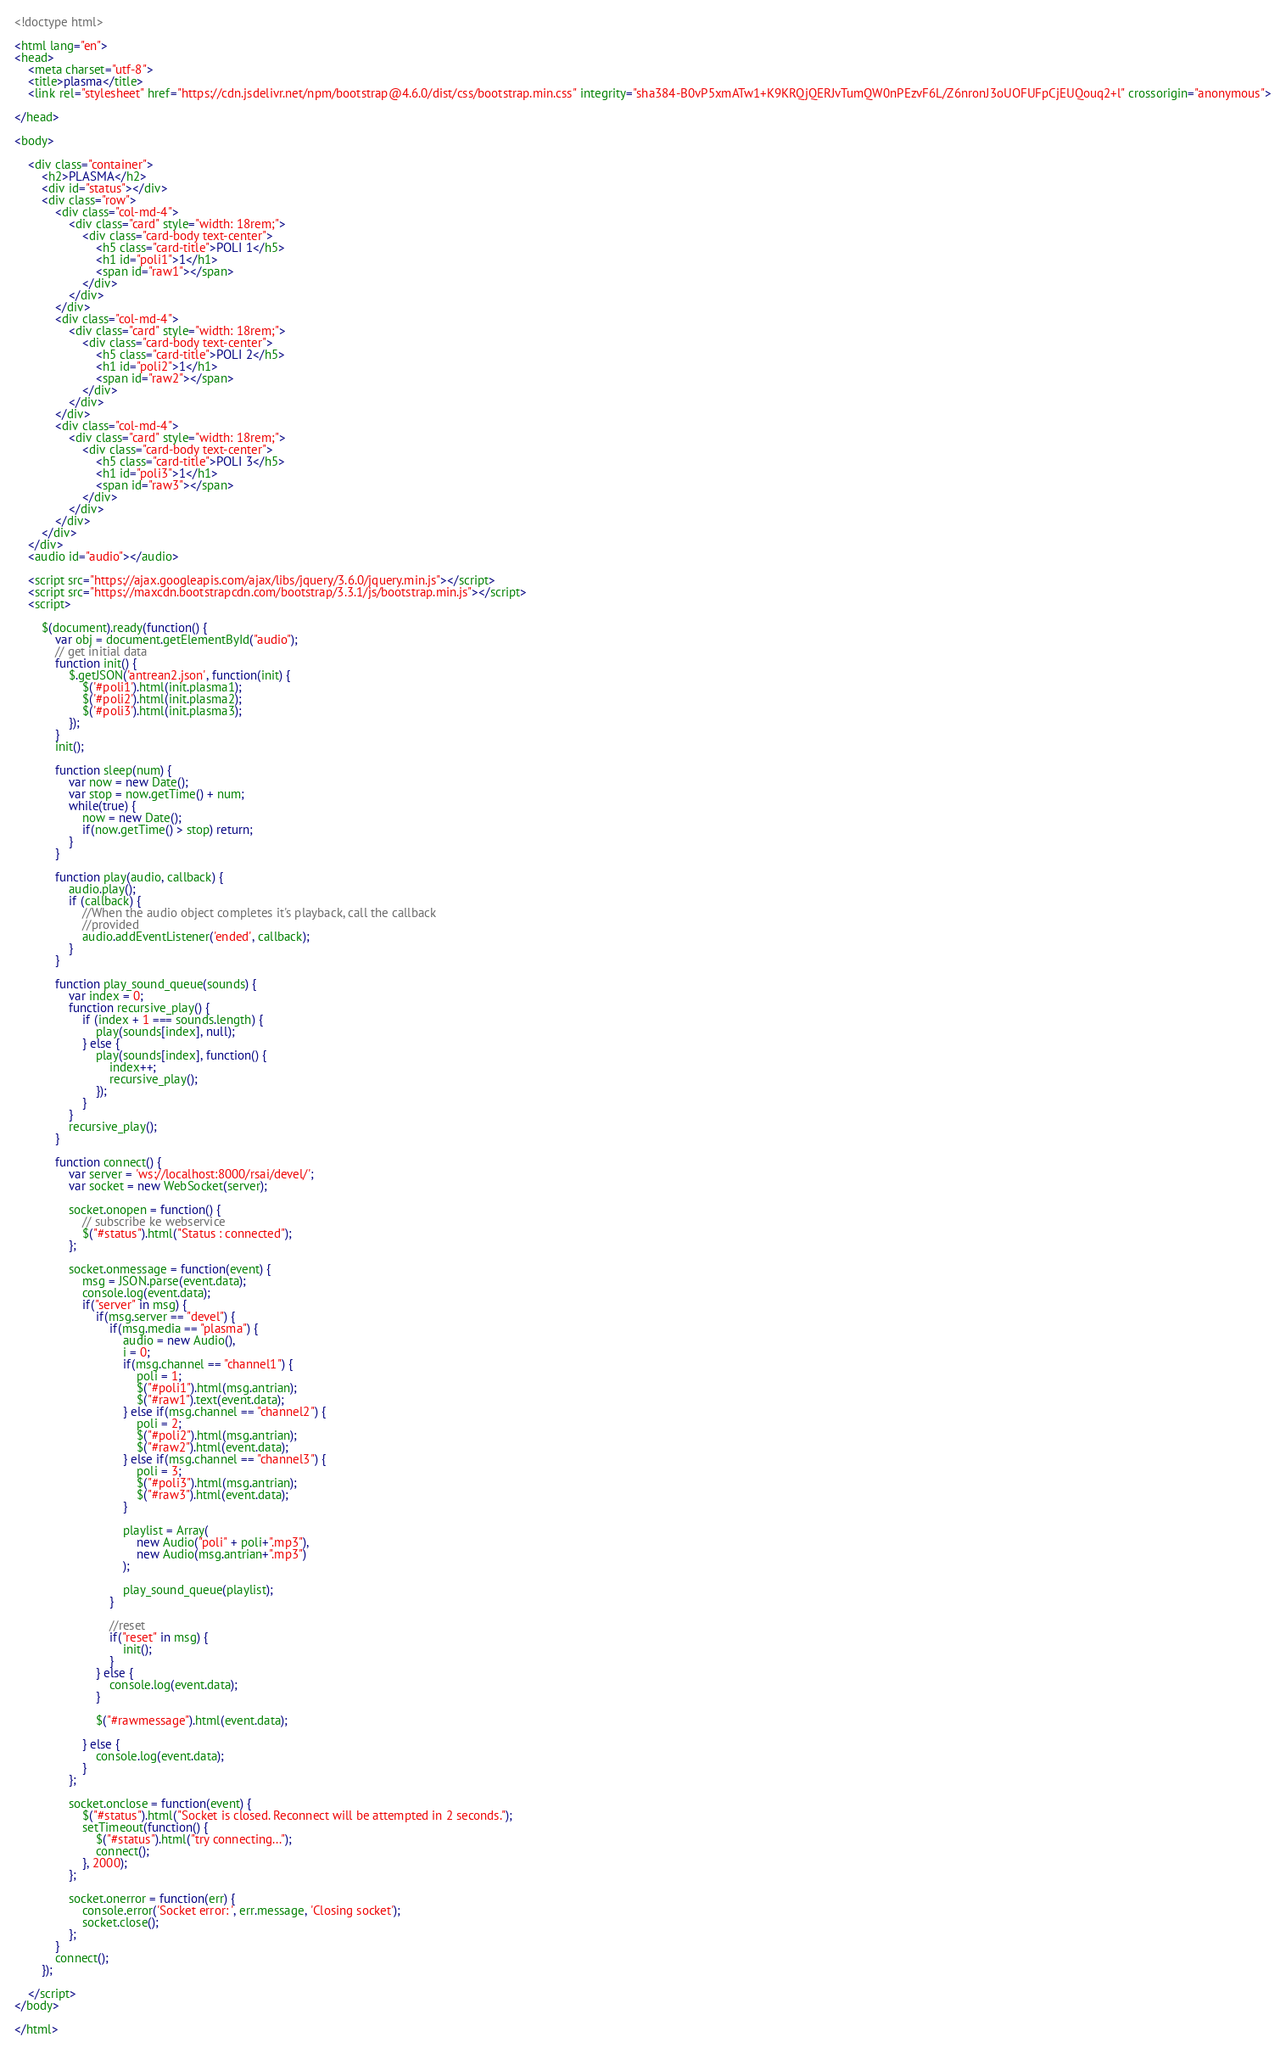Convert code to text. <code><loc_0><loc_0><loc_500><loc_500><_HTML_><!doctype html>

<html lang="en">
<head>
    <meta charset="utf-8">
    <title>plasma</title>
    <link rel="stylesheet" href="https://cdn.jsdelivr.net/npm/bootstrap@4.6.0/dist/css/bootstrap.min.css" integrity="sha384-B0vP5xmATw1+K9KRQjQERJvTumQW0nPEzvF6L/Z6nronJ3oUOFUFpCjEUQouq2+l" crossorigin="anonymous">
        
</head>

<body>

    <div class="container">
        <h2>PLASMA</h2>
        <div id="status"></div>
        <div class="row">
            <div class="col-md-4">
                <div class="card" style="width: 18rem;">
                    <div class="card-body text-center">
                        <h5 class="card-title">POLI 1</h5>
                        <h1 id="poli1">1</h1>
                        <span id="raw1"></span>
                    </div>
                </div>
            </div>
            <div class="col-md-4">
                <div class="card" style="width: 18rem;">
                    <div class="card-body text-center">
                        <h5 class="card-title">POLI 2</h5>
                        <h1 id="poli2">1</h1>
                        <span id="raw2"></span>
                    </div>
                </div>
            </div>
            <div class="col-md-4">
                <div class="card" style="width: 18rem;">
                    <div class="card-body text-center">
                        <h5 class="card-title">POLI 3</h5>
                        <h1 id="poli3">1</h1>
                        <span id="raw3"></span>
                    </div>
                </div>
            </div>
        </div>
    </div>
    <audio id="audio"></audio>

    <script src="https://ajax.googleapis.com/ajax/libs/jquery/3.6.0/jquery.min.js"></script>
    <script src="https://maxcdn.bootstrapcdn.com/bootstrap/3.3.1/js/bootstrap.min.js"></script>
    <script>
        
		$(document).ready(function() {
            var obj = document.getElementById("audio");
            // get initial data
            function init() {
                $.getJSON('antrean2.json', function(init) {
                    $('#poli1').html(init.plasma1);
                    $('#poli2').html(init.plasma2);
                    $('#poli3').html(init.plasma3);
                });
            }
            init();

            function sleep(num) {
                var now = new Date();
                var stop = now.getTime() + num;
                while(true) {
                    now = new Date();
                    if(now.getTime() > stop) return;
                }
            }

            function play(audio, callback) {
                audio.play();
                if (callback) {
                    //When the audio object completes it's playback, call the callback
                    //provided      
                    audio.addEventListener('ended', callback);
                }
            }

            function play_sound_queue(sounds) {
                var index = 0;
                function recursive_play() {
                    if (index + 1 === sounds.length) {
                        play(sounds[index], null);
                    } else {
                        play(sounds[index], function() {
                            index++;
                            recursive_play();
                        });
                    }
                }
                recursive_play();
            }

            function connect() {
                var server = 'ws://localhost:8000/rsai/devel/';
                var socket = new WebSocket(server);

                socket.onopen = function() {
                    // subscribe ke webservice
                    $("#status").html("Status : connected");
                };

                socket.onmessage = function(event) {
                    msg = JSON.parse(event.data);
                    console.log(event.data);
                    if("server" in msg) {
                        if(msg.server == "devel") {
                            if(msg.media == "plasma") {
                                audio = new Audio(),
                                i = 0;
                                if(msg.channel == "channel1") {
                                    poli = 1;
                                    $("#poli1").html(msg.antrian);
                                    $("#raw1").text(event.data);
                                } else if(msg.channel == "channel2") { 
                                    poli = 2;
                                    $("#poli2").html(msg.antrian);
                                    $("#raw2").html(event.data);
                                } else if(msg.channel == "channel3") { 
                                    poli = 3;
                                    $("#poli3").html(msg.antrian);
                                    $("#raw3").html(event.data);
                                }

                                playlist = Array( 
                                    new Audio("poli" + poli+".mp3"), 
                                    new Audio(msg.antrian+".mp3")
                                );
                                
                                play_sound_queue(playlist);
                            }
                            
                            //reset
                            if("reset" in msg) {
                                init();
                            }    
                        } else {
                            console.log(event.data);
                        }

                        $("#rawmessage").html(event.data);
                        
                    } else {
                        console.log(event.data);
                    }
                };

                socket.onclose = function(event) {    
                    $("#status").html("Socket is closed. Reconnect will be attempted in 2 seconds.");
                    setTimeout(function() {
                        $("#status").html("try connecting...");
                        connect();
                    }, 2000);
                };

                socket.onerror = function(err) {
                    console.error('Socket error: ', err.message, 'Closing socket');
                    socket.close();
                };
            }
            connect();
		});

    </script>
</body>

</html>
</code> 